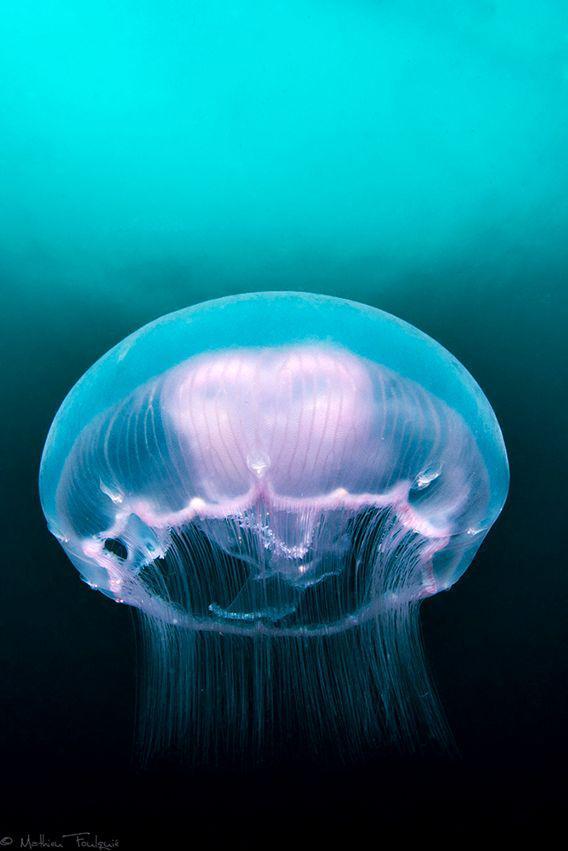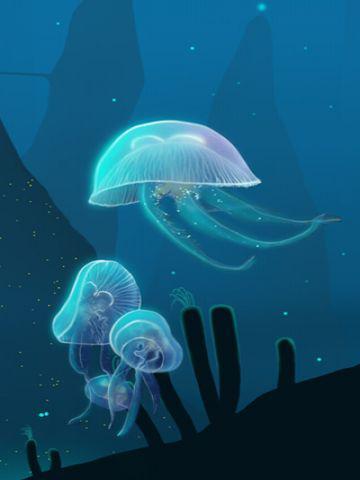The first image is the image on the left, the second image is the image on the right. Examine the images to the left and right. Is the description "The jellyfish in the image on the right is pink." accurate? Answer yes or no. No. The first image is the image on the left, the second image is the image on the right. Examine the images to the left and right. Is the description "An image features one large anemone with a dome-like projection on one end and the other covered in small colored dots." accurate? Answer yes or no. No. 